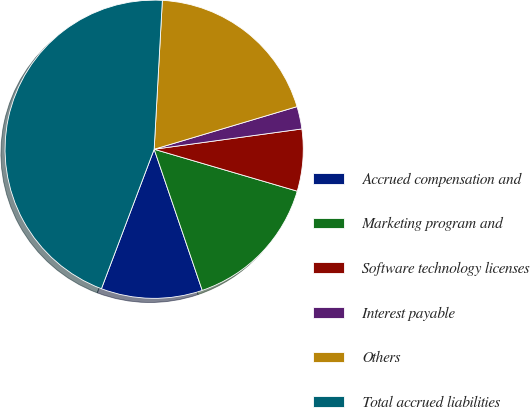<chart> <loc_0><loc_0><loc_500><loc_500><pie_chart><fcel>Accrued compensation and<fcel>Marketing program and<fcel>Software technology licenses<fcel>Interest payable<fcel>Others<fcel>Total accrued liabilities<nl><fcel>10.98%<fcel>15.24%<fcel>6.71%<fcel>2.44%<fcel>19.51%<fcel>45.12%<nl></chart> 